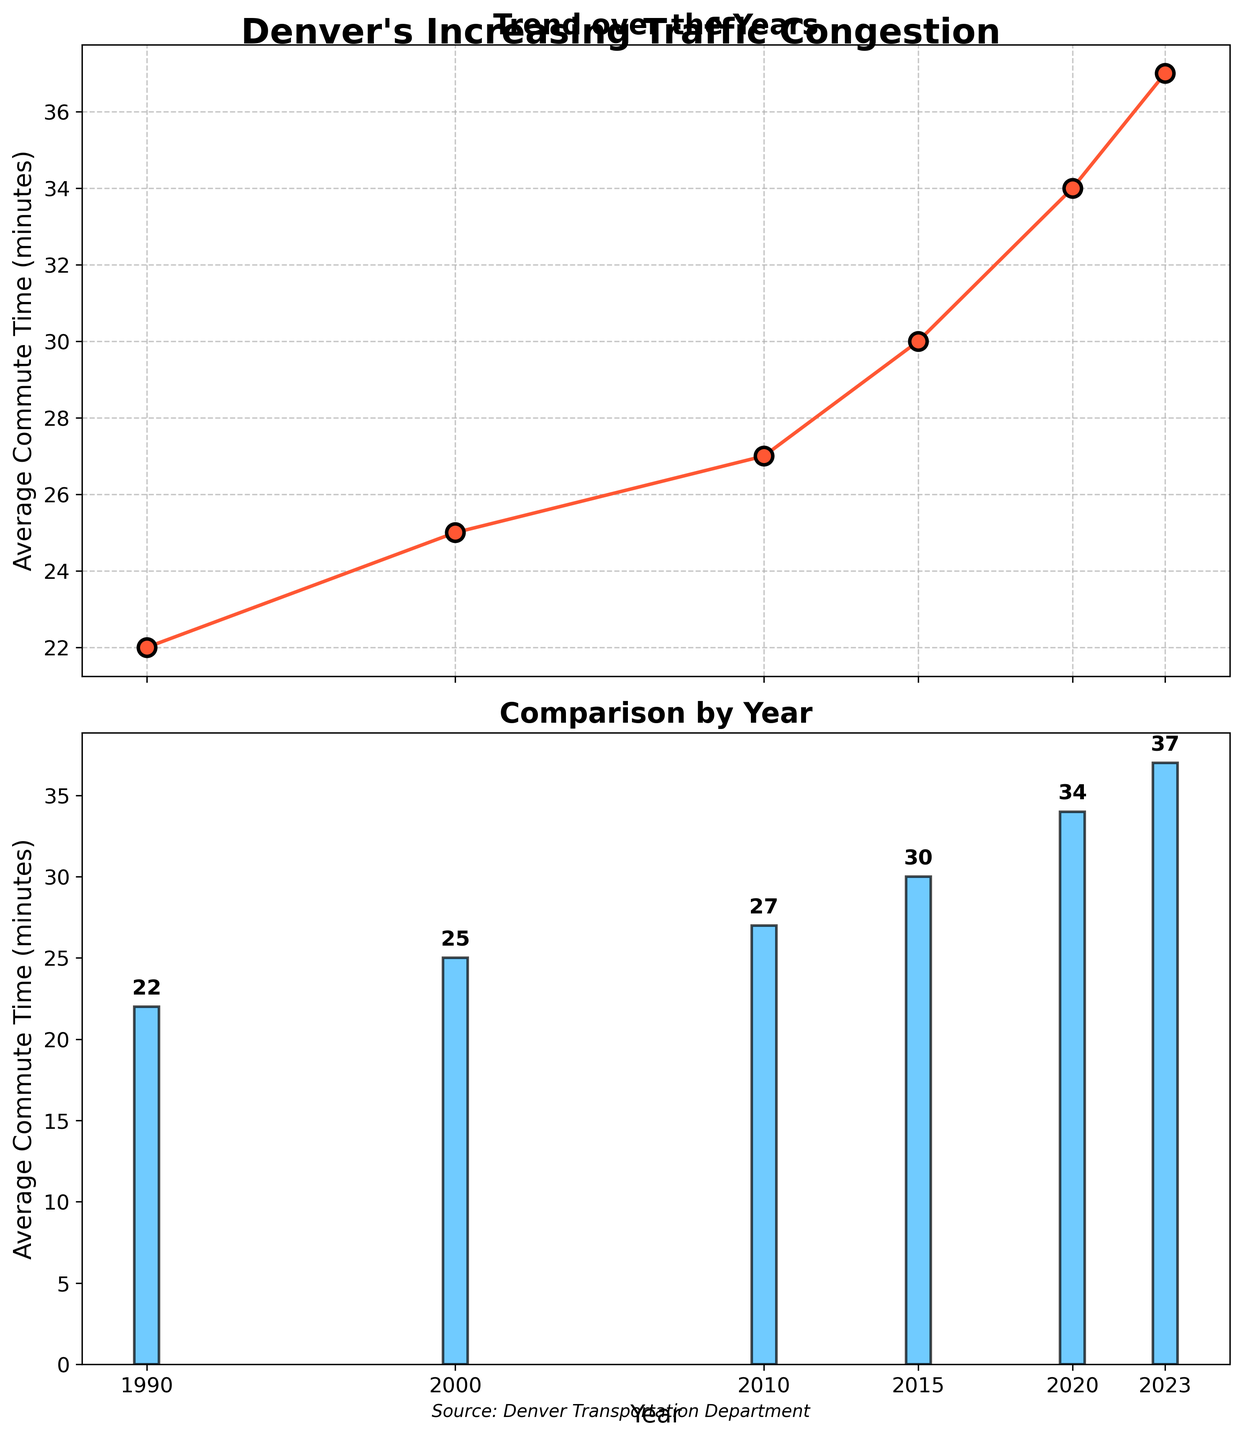What's the title of the figure? The title is displayed at the top center of the figure. It reads "Denver's Increasing Traffic Congestion".
Answer: Denver's Increasing Traffic Congestion How many total data points are plotted in the figure? Each year listed on the x-axis corresponds to a data point. There are six years displayed: 1990, 2000, 2010, 2015, 2020, 2023.
Answer: 6 What is the average commute time in 2023? Find the bar or point corresponding to 2023 on both the line plot and bar plot sections. It shows 37 minutes.
Answer: 37 minutes Describe the trend in average commute times from 1990 to 2023. Observing both the line and bar plots, the average commute time increases over the years from 22 minutes in 1990 to 37 minutes in 2023.
Answer: Increasing Which year saw the highest average commute time? By looking at the top of the bars (or at the highest point in the line plot), 2023 has the highest average commute time at 37 minutes.
Answer: 2023 Compare the average commute times between 2000 and 2010. Which year had a higher commute time? In the plots, 2000 has a commute time of 25 minutes, while 2010 has 27 minutes. Therefore, 2010 had a higher average commute time.
Answer: 2010 What is the difference in average commute time between the years 1990 and 2023? Identify the commute times for 1990 and 2023, then subtract them: 37 minutes (2023) - 22 minutes (1990) = 15 minutes.
Answer: 15 minutes What kind of plots are used in the figure? The figure uses two types of plots: a line plot in the top subplot and a bar plot in the bottom subplot.
Answer: Line plot and bar plot What is the source of the data? The source is noted at the bottom of the figure, which reads: 'Source: Denver Transportation Department'.
Answer: Denver Transportation Department 